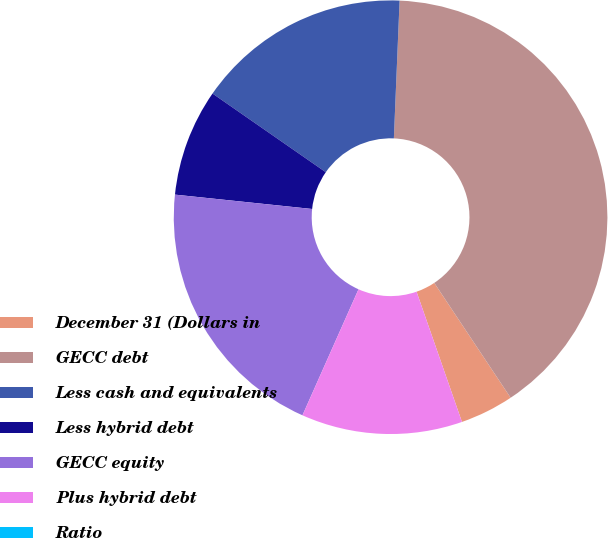<chart> <loc_0><loc_0><loc_500><loc_500><pie_chart><fcel>December 31 (Dollars in<fcel>GECC debt<fcel>Less cash and equivalents<fcel>Less hybrid debt<fcel>GECC equity<fcel>Plus hybrid debt<fcel>Ratio<nl><fcel>4.0%<fcel>40.0%<fcel>16.0%<fcel>8.0%<fcel>20.0%<fcel>12.0%<fcel>0.0%<nl></chart> 